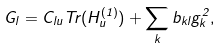<formula> <loc_0><loc_0><loc_500><loc_500>G _ { l } = C _ { l u } T r ( H _ { u } ^ { ( 1 ) } ) + \sum _ { k } b _ { k l } g _ { k } ^ { 2 } ,</formula> 